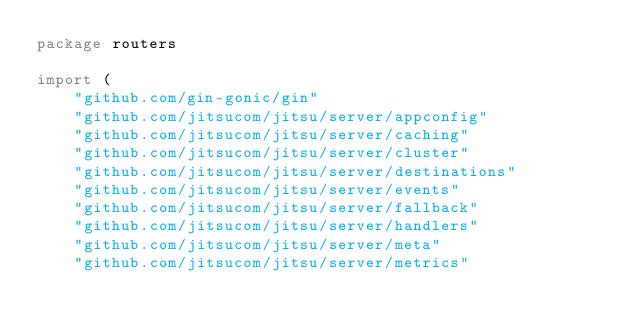<code> <loc_0><loc_0><loc_500><loc_500><_Go_>package routers

import (
	"github.com/gin-gonic/gin"
	"github.com/jitsucom/jitsu/server/appconfig"
	"github.com/jitsucom/jitsu/server/caching"
	"github.com/jitsucom/jitsu/server/cluster"
	"github.com/jitsucom/jitsu/server/destinations"
	"github.com/jitsucom/jitsu/server/events"
	"github.com/jitsucom/jitsu/server/fallback"
	"github.com/jitsucom/jitsu/server/handlers"
	"github.com/jitsucom/jitsu/server/meta"
	"github.com/jitsucom/jitsu/server/metrics"</code> 